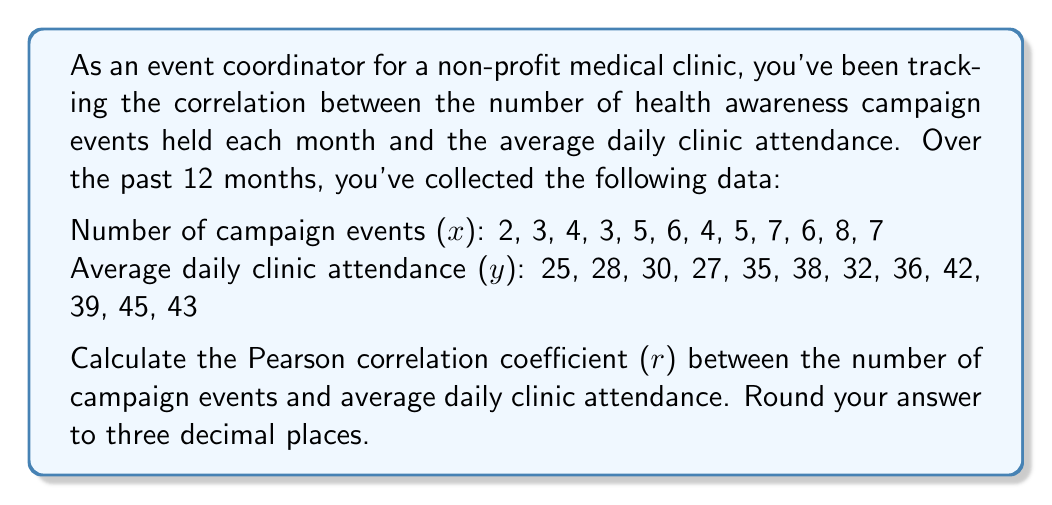What is the answer to this math problem? To calculate the Pearson correlation coefficient (r), we'll use the formula:

$$ r = \frac{n\sum xy - \sum x \sum y}{\sqrt{[n\sum x^2 - (\sum x)^2][n\sum y^2 - (\sum y)^2]}} $$

Let's calculate each component:

1. $n = 12$ (number of data points)
2. $\sum x = 60$ (sum of campaign events)
3. $\sum y = 420$ (sum of average daily attendance)
4. $\sum xy = 2,226$ (sum of products)
5. $\sum x^2 = 324$ (sum of squared campaign events)
6. $\sum y^2 = 15,146$ (sum of squared attendance)

Now, let's substitute these values into the formula:

$$ r = \frac{12(2,226) - 60(420)}{\sqrt{[12(324) - 60^2][12(15,146) - 420^2]}} $$

$$ r = \frac{26,712 - 25,200}{\sqrt{(3,888 - 3,600)(181,752 - 176,400)}} $$

$$ r = \frac{1,512}{\sqrt{288 * 5,352}} $$

$$ r = \frac{1,512}{\sqrt{1,541,376}} $$

$$ r = \frac{1,512}{1,241.52} $$

$$ r \approx 0.9181 $$

Rounding to three decimal places, we get 0.918.
Answer: 0.918 